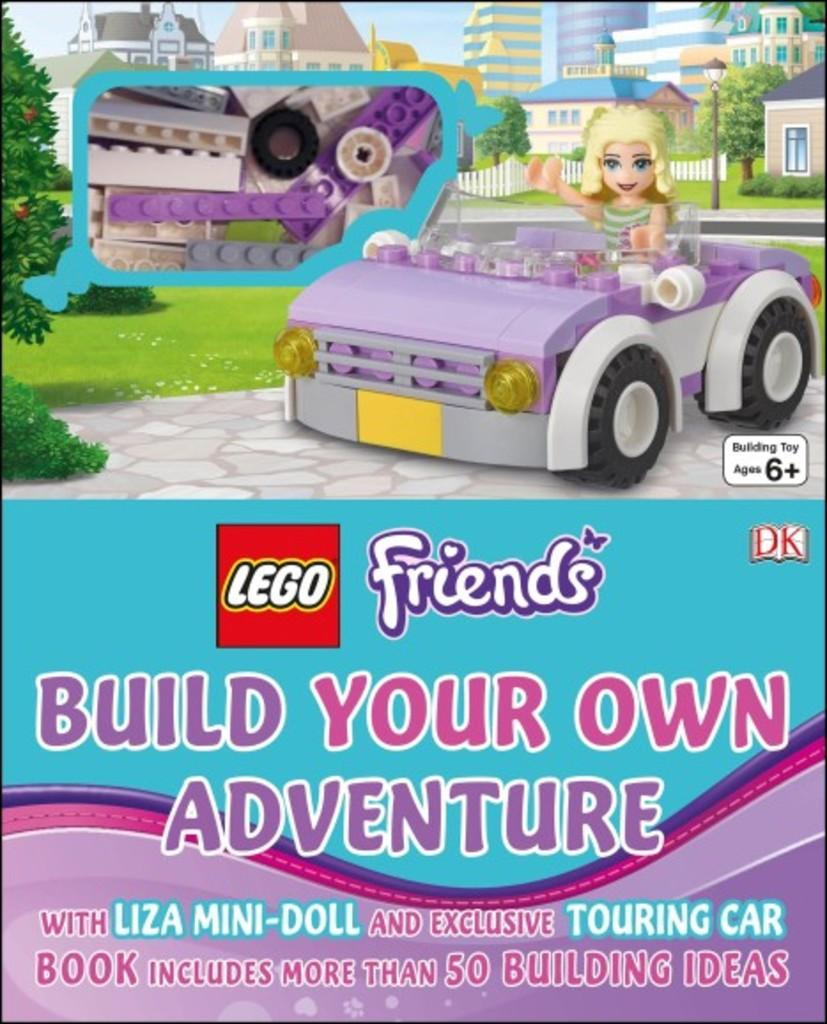What is the main subject of the picture? The main subject of the picture is a car. Who or what is inside the car? There is a doll sitting in the car. What can be seen in the background of the picture? There are trees and plants in the background of the picture. Is there any text or writing visible in the picture? Yes, there is text or writing visible in the picture. How many girls are riding the horses in the picture? There are no girls or horses present in the picture; it features a car with a doll inside. 